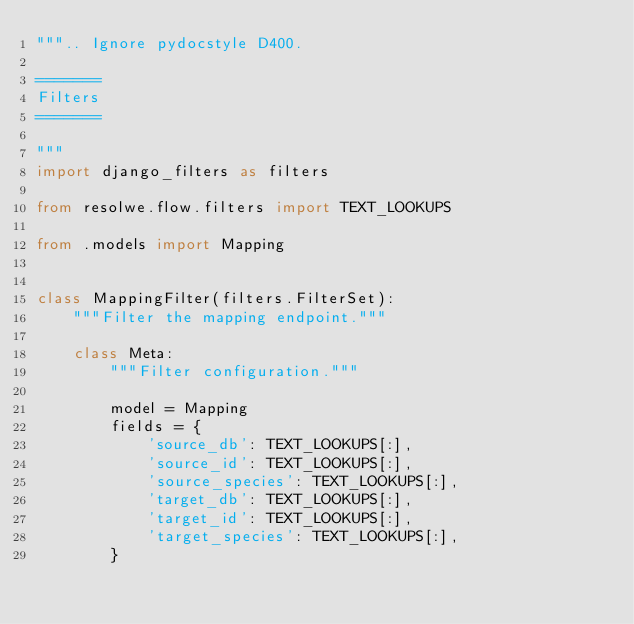<code> <loc_0><loc_0><loc_500><loc_500><_Python_>""".. Ignore pydocstyle D400.

=======
Filters
=======

"""
import django_filters as filters

from resolwe.flow.filters import TEXT_LOOKUPS

from .models import Mapping


class MappingFilter(filters.FilterSet):
    """Filter the mapping endpoint."""

    class Meta:
        """Filter configuration."""

        model = Mapping
        fields = {
            'source_db': TEXT_LOOKUPS[:],
            'source_id': TEXT_LOOKUPS[:],
            'source_species': TEXT_LOOKUPS[:],
            'target_db': TEXT_LOOKUPS[:],
            'target_id': TEXT_LOOKUPS[:],
            'target_species': TEXT_LOOKUPS[:],
        }
</code> 